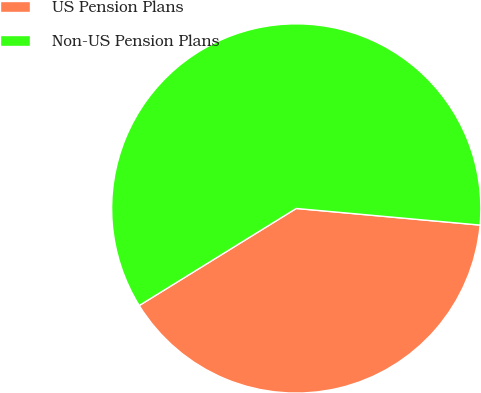Convert chart to OTSL. <chart><loc_0><loc_0><loc_500><loc_500><pie_chart><fcel>US Pension Plans<fcel>Non-US Pension Plans<nl><fcel>39.75%<fcel>60.25%<nl></chart> 